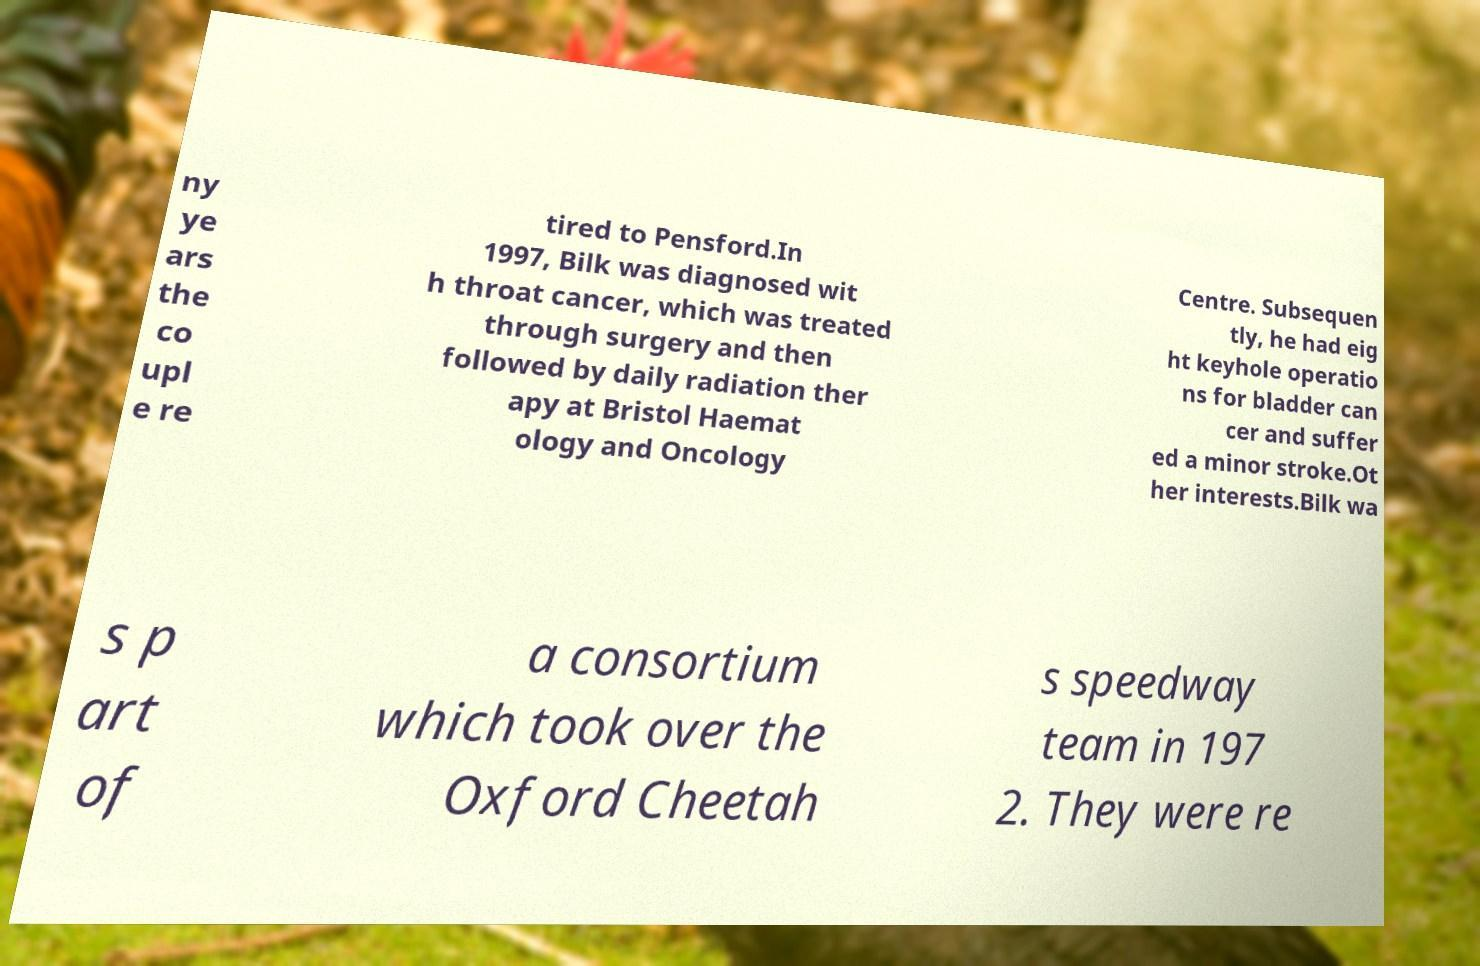There's text embedded in this image that I need extracted. Can you transcribe it verbatim? ny ye ars the co upl e re tired to Pensford.In 1997, Bilk was diagnosed wit h throat cancer, which was treated through surgery and then followed by daily radiation ther apy at Bristol Haemat ology and Oncology Centre. Subsequen tly, he had eig ht keyhole operatio ns for bladder can cer and suffer ed a minor stroke.Ot her interests.Bilk wa s p art of a consortium which took over the Oxford Cheetah s speedway team in 197 2. They were re 